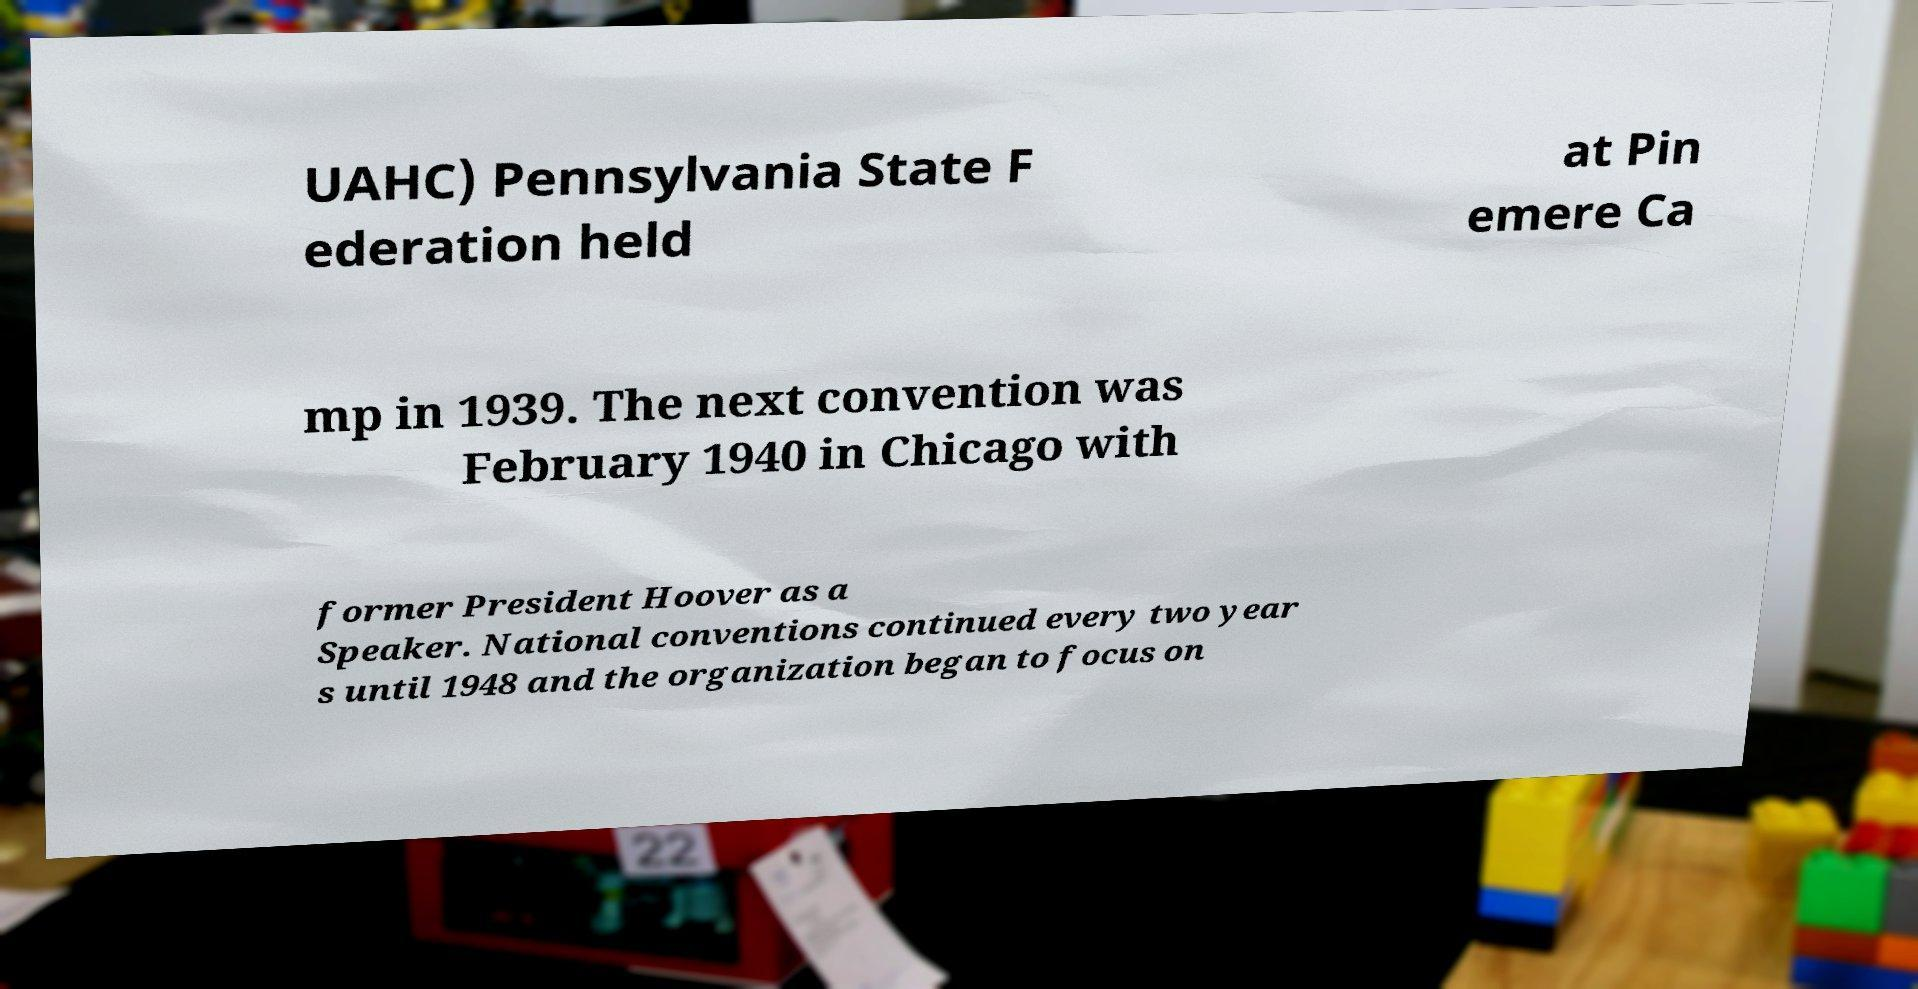Can you accurately transcribe the text from the provided image for me? UAHC) Pennsylvania State F ederation held at Pin emere Ca mp in 1939. The next convention was February 1940 in Chicago with former President Hoover as a Speaker. National conventions continued every two year s until 1948 and the organization began to focus on 